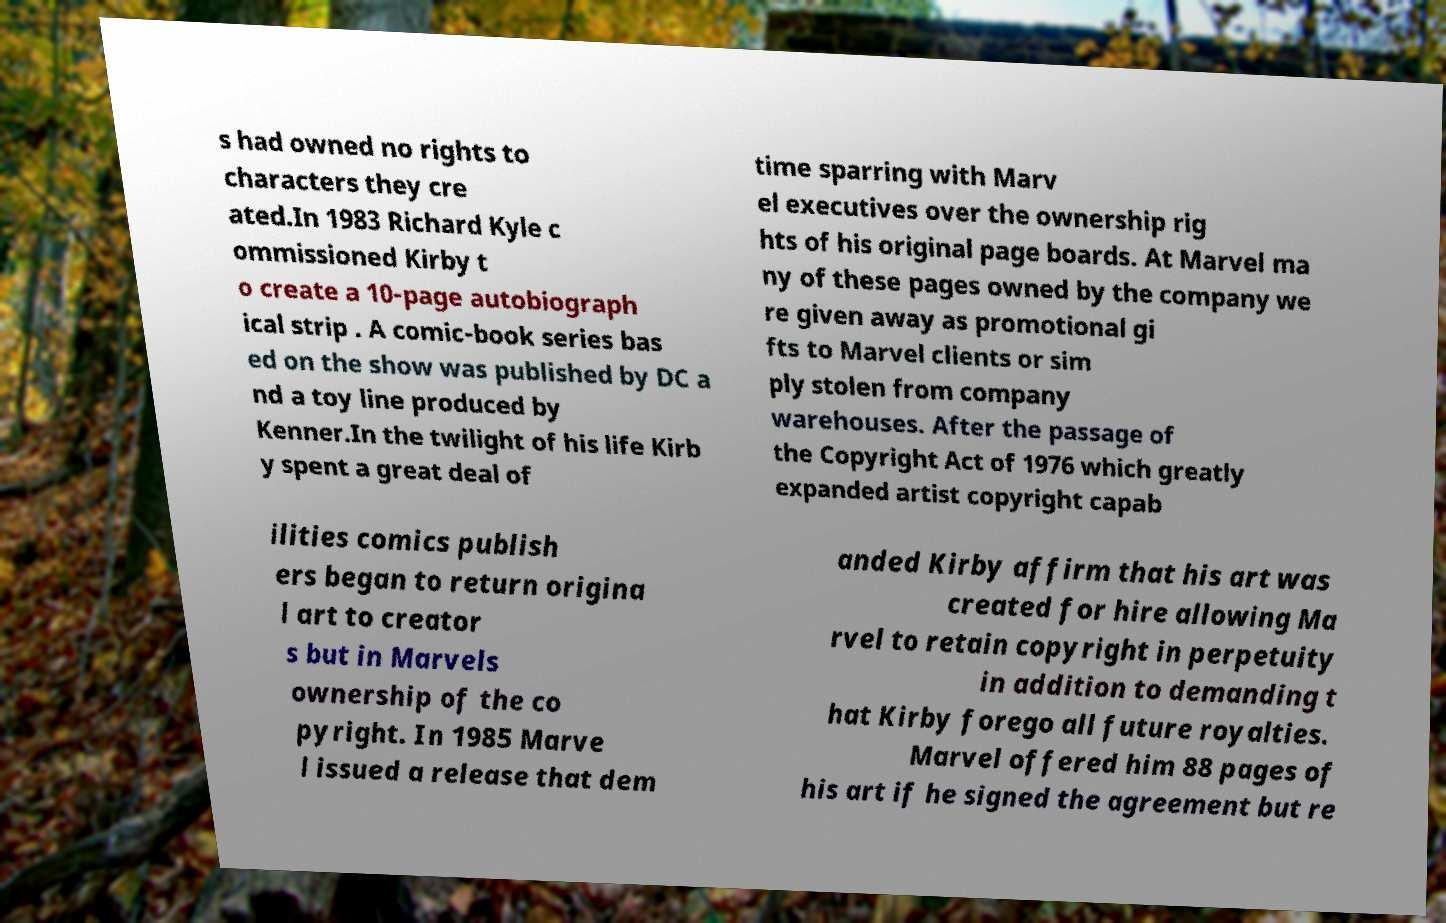Could you assist in decoding the text presented in this image and type it out clearly? s had owned no rights to characters they cre ated.In 1983 Richard Kyle c ommissioned Kirby t o create a 10-page autobiograph ical strip . A comic-book series bas ed on the show was published by DC a nd a toy line produced by Kenner.In the twilight of his life Kirb y spent a great deal of time sparring with Marv el executives over the ownership rig hts of his original page boards. At Marvel ma ny of these pages owned by the company we re given away as promotional gi fts to Marvel clients or sim ply stolen from company warehouses. After the passage of the Copyright Act of 1976 which greatly expanded artist copyright capab ilities comics publish ers began to return origina l art to creator s but in Marvels ownership of the co pyright. In 1985 Marve l issued a release that dem anded Kirby affirm that his art was created for hire allowing Ma rvel to retain copyright in perpetuity in addition to demanding t hat Kirby forego all future royalties. Marvel offered him 88 pages of his art if he signed the agreement but re 